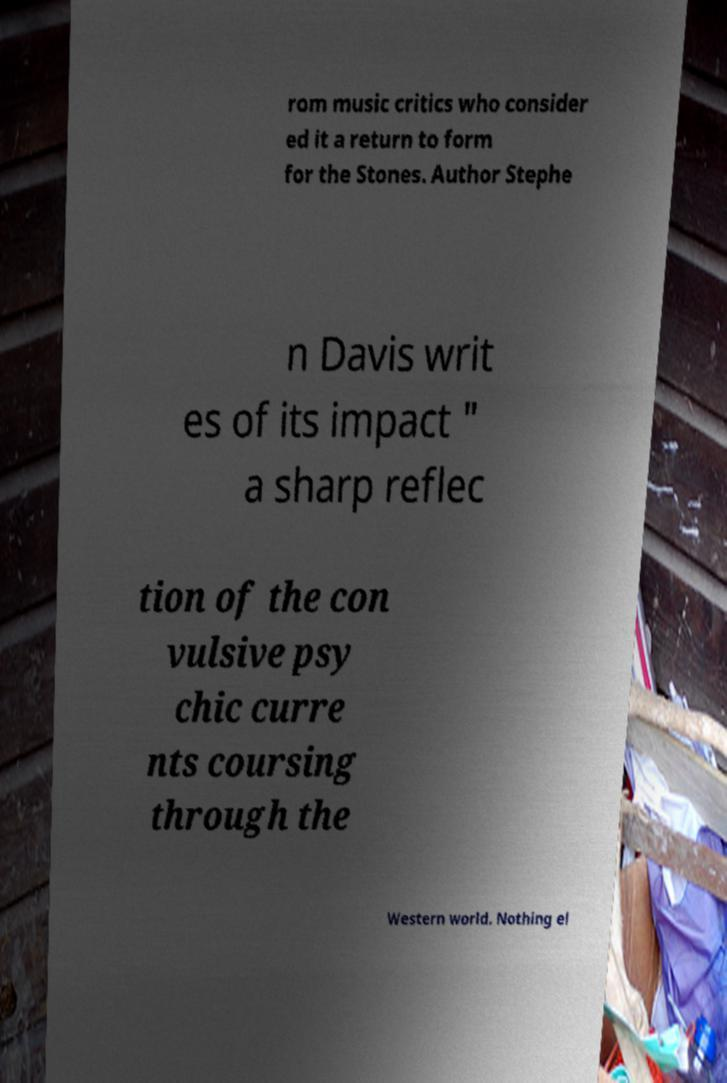Please read and relay the text visible in this image. What does it say? rom music critics who consider ed it a return to form for the Stones. Author Stephe n Davis writ es of its impact " a sharp reflec tion of the con vulsive psy chic curre nts coursing through the Western world. Nothing el 